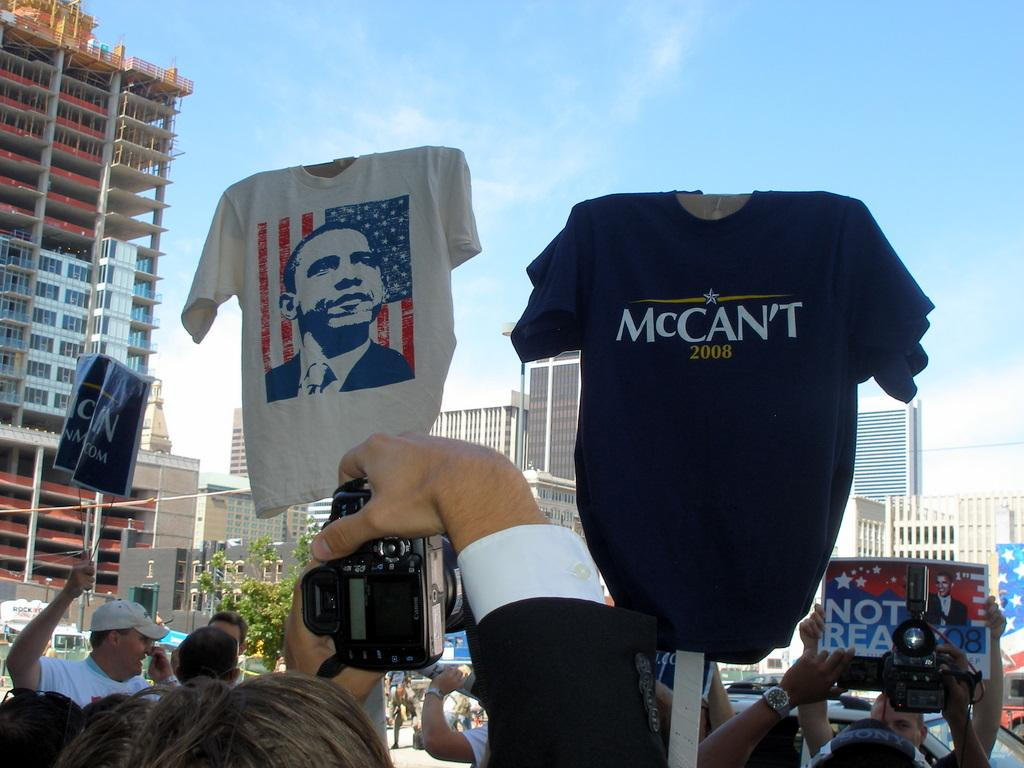<image>
Provide a brief description of the given image. A tee shirt that says McCant 2008 being held up above a group of people. 